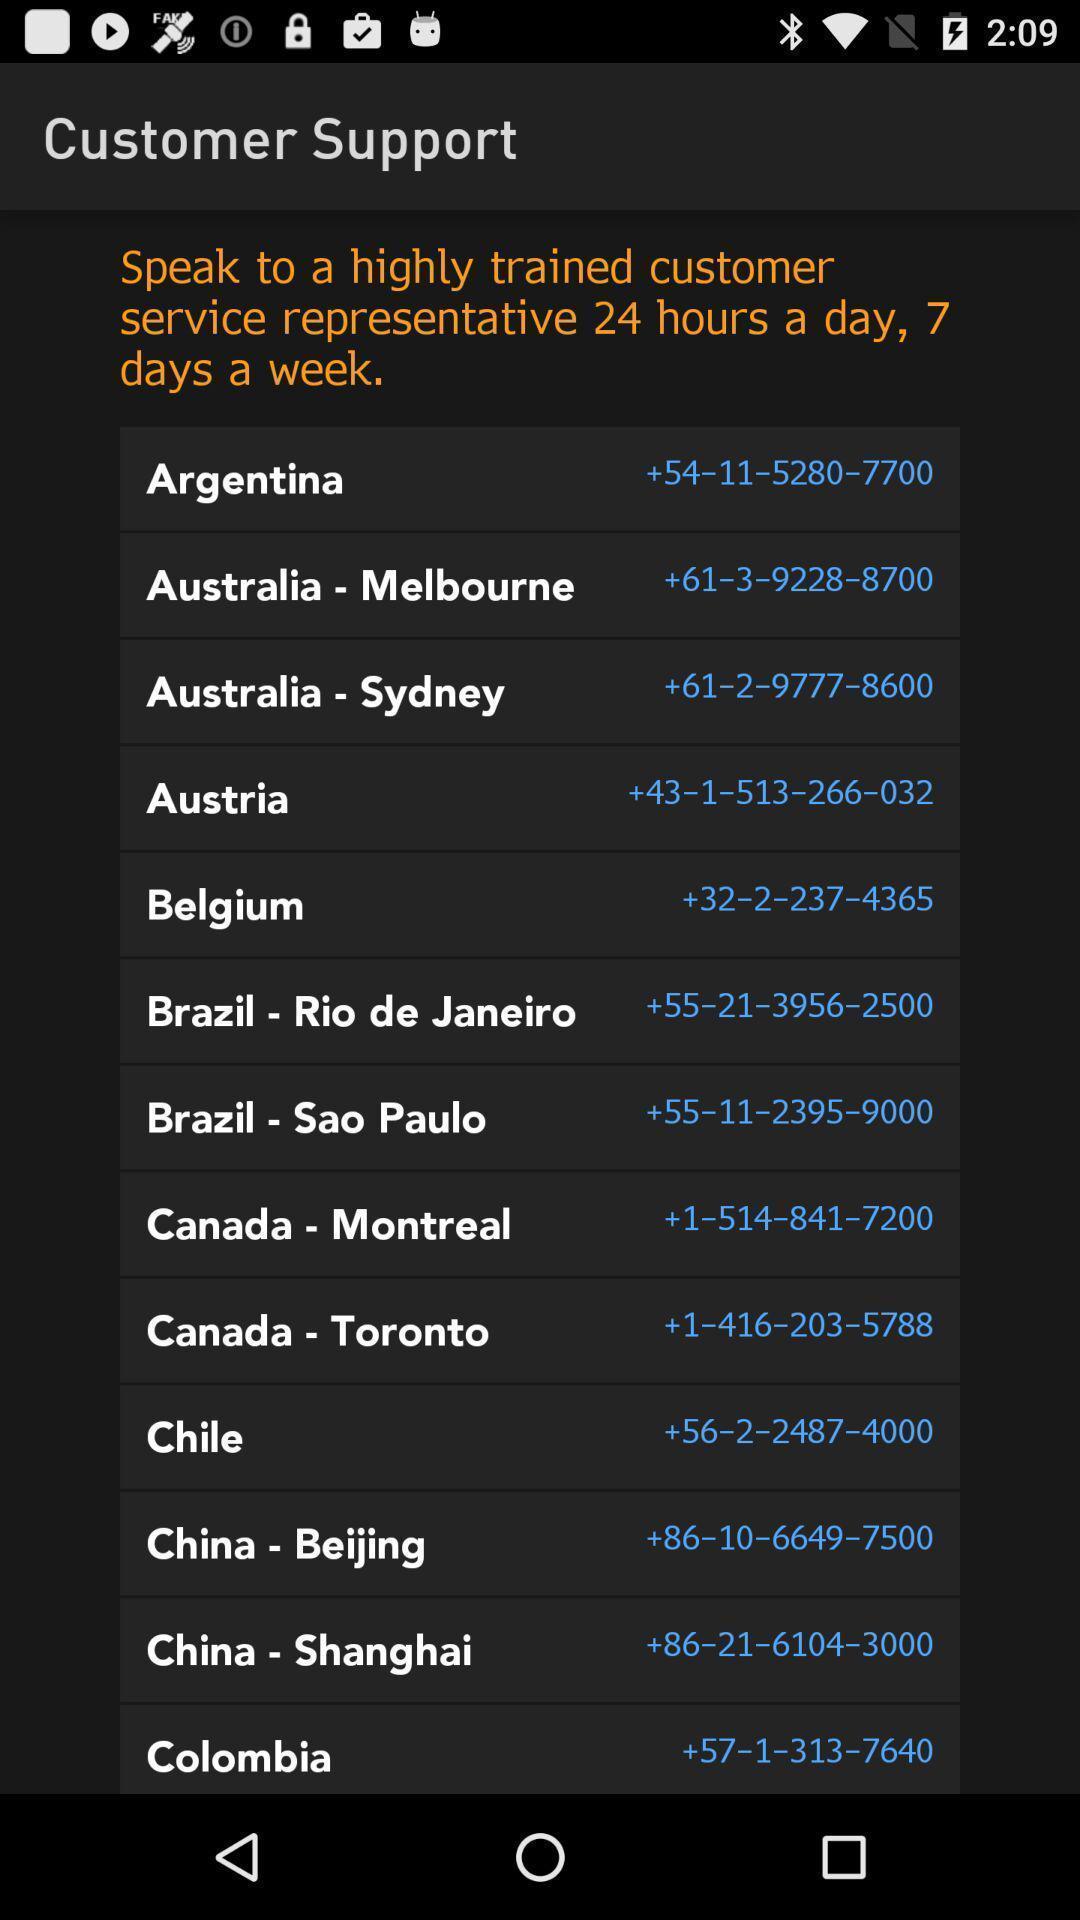What details can you identify in this image? Page displaying the information of the customer support. 